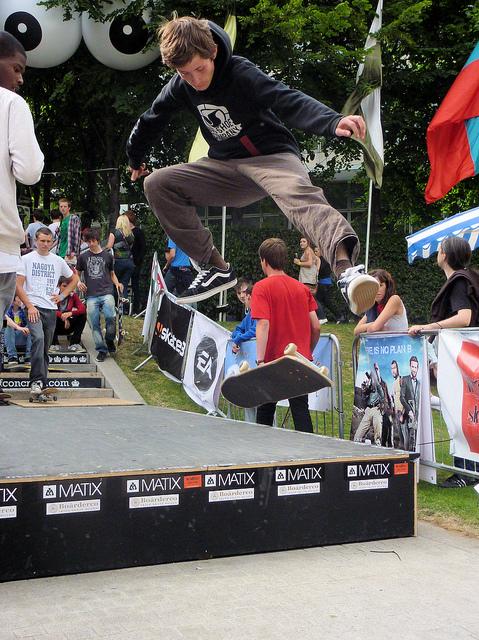Is this a competition?
Keep it brief. Yes. What is under the boy?
Be succinct. Skateboard. What event is this?
Give a very brief answer. Skateboarding. Where is the skateboard?
Answer briefly. In air. 